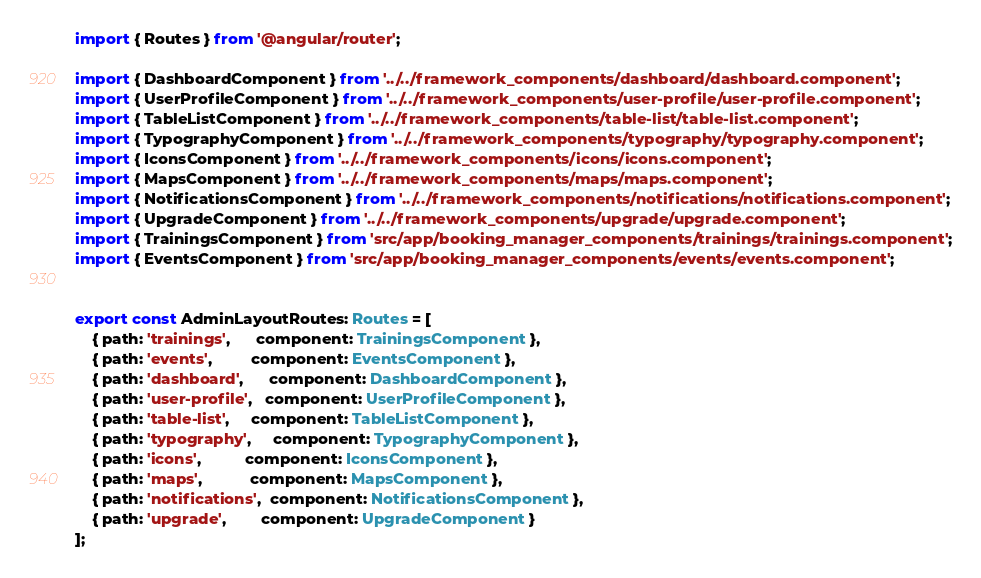<code> <loc_0><loc_0><loc_500><loc_500><_TypeScript_>import { Routes } from '@angular/router';

import { DashboardComponent } from '../../framework_components/dashboard/dashboard.component';
import { UserProfileComponent } from '../../framework_components/user-profile/user-profile.component';
import { TableListComponent } from '../../framework_components/table-list/table-list.component';
import { TypographyComponent } from '../../framework_components/typography/typography.component';
import { IconsComponent } from '../../framework_components/icons/icons.component';
import { MapsComponent } from '../../framework_components/maps/maps.component';
import { NotificationsComponent } from '../../framework_components/notifications/notifications.component';
import { UpgradeComponent } from '../../framework_components/upgrade/upgrade.component';
import { TrainingsComponent } from 'src/app/booking_manager_components/trainings/trainings.component';
import { EventsComponent } from 'src/app/booking_manager_components/events/events.component';


export const AdminLayoutRoutes: Routes = [
    { path: 'trainings',      component: TrainingsComponent },
    { path: 'events',         component: EventsComponent },
    { path: 'dashboard',      component: DashboardComponent },
    { path: 'user-profile',   component: UserProfileComponent },
    { path: 'table-list',     component: TableListComponent },
    { path: 'typography',     component: TypographyComponent },
    { path: 'icons',          component: IconsComponent },
    { path: 'maps',           component: MapsComponent },
    { path: 'notifications',  component: NotificationsComponent },
    { path: 'upgrade',        component: UpgradeComponent }
];
</code> 